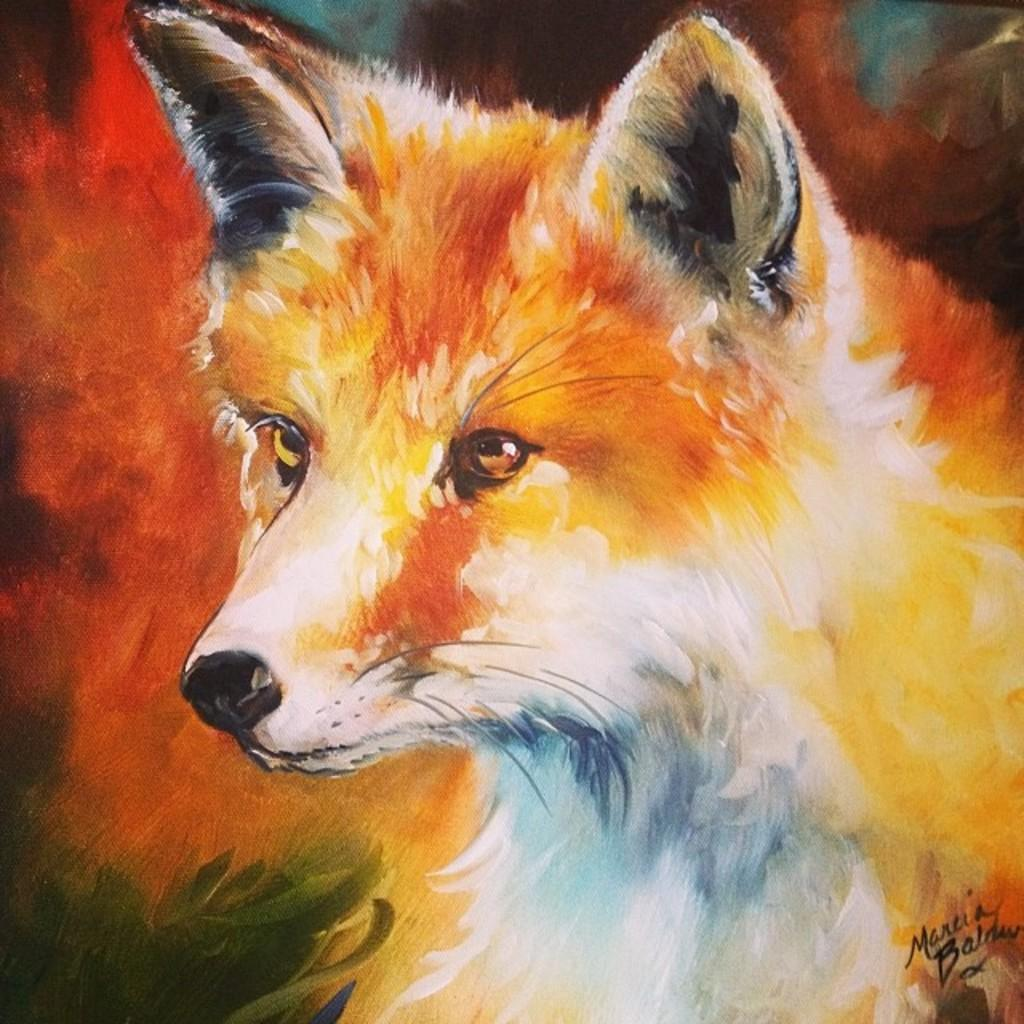What is depicted on the dog in the image? There is a painting on a dog in the image. What can be seen on the painting itself? There are words written on the painting. Can you see the dog and the person it is fighting in the image? There is no fight or person present in the image; it only features a painting on a dog with words written on it. 